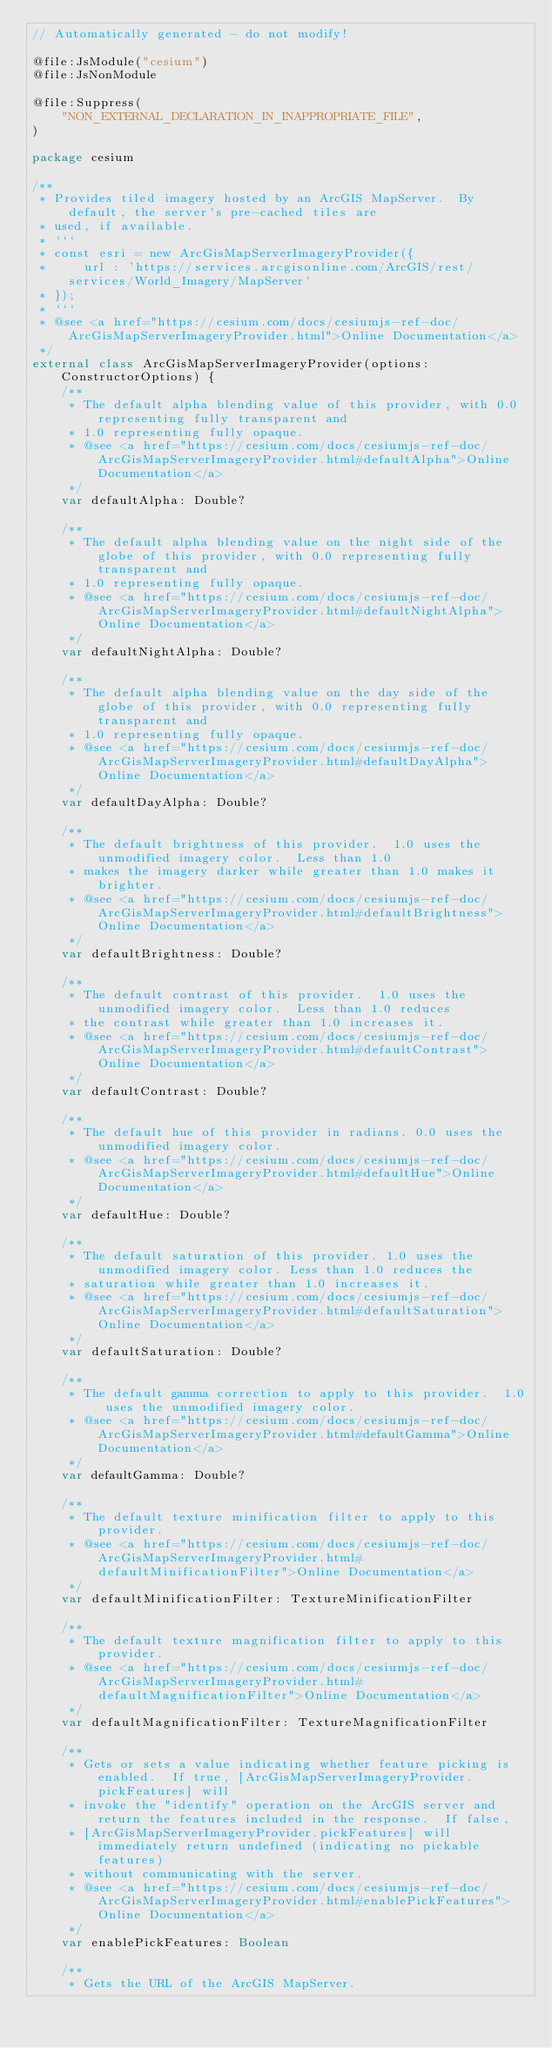<code> <loc_0><loc_0><loc_500><loc_500><_Kotlin_>// Automatically generated - do not modify!

@file:JsModule("cesium")
@file:JsNonModule

@file:Suppress(
    "NON_EXTERNAL_DECLARATION_IN_INAPPROPRIATE_FILE",
)

package cesium

/**
 * Provides tiled imagery hosted by an ArcGIS MapServer.  By default, the server's pre-cached tiles are
 * used, if available.
 * ```
 * const esri = new ArcGisMapServerImageryProvider({
 *     url : 'https://services.arcgisonline.com/ArcGIS/rest/services/World_Imagery/MapServer'
 * });
 * ```
 * @see <a href="https://cesium.com/docs/cesiumjs-ref-doc/ArcGisMapServerImageryProvider.html">Online Documentation</a>
 */
external class ArcGisMapServerImageryProvider(options: ConstructorOptions) {
    /**
     * The default alpha blending value of this provider, with 0.0 representing fully transparent and
     * 1.0 representing fully opaque.
     * @see <a href="https://cesium.com/docs/cesiumjs-ref-doc/ArcGisMapServerImageryProvider.html#defaultAlpha">Online Documentation</a>
     */
    var defaultAlpha: Double?

    /**
     * The default alpha blending value on the night side of the globe of this provider, with 0.0 representing fully transparent and
     * 1.0 representing fully opaque.
     * @see <a href="https://cesium.com/docs/cesiumjs-ref-doc/ArcGisMapServerImageryProvider.html#defaultNightAlpha">Online Documentation</a>
     */
    var defaultNightAlpha: Double?

    /**
     * The default alpha blending value on the day side of the globe of this provider, with 0.0 representing fully transparent and
     * 1.0 representing fully opaque.
     * @see <a href="https://cesium.com/docs/cesiumjs-ref-doc/ArcGisMapServerImageryProvider.html#defaultDayAlpha">Online Documentation</a>
     */
    var defaultDayAlpha: Double?

    /**
     * The default brightness of this provider.  1.0 uses the unmodified imagery color.  Less than 1.0
     * makes the imagery darker while greater than 1.0 makes it brighter.
     * @see <a href="https://cesium.com/docs/cesiumjs-ref-doc/ArcGisMapServerImageryProvider.html#defaultBrightness">Online Documentation</a>
     */
    var defaultBrightness: Double?

    /**
     * The default contrast of this provider.  1.0 uses the unmodified imagery color.  Less than 1.0 reduces
     * the contrast while greater than 1.0 increases it.
     * @see <a href="https://cesium.com/docs/cesiumjs-ref-doc/ArcGisMapServerImageryProvider.html#defaultContrast">Online Documentation</a>
     */
    var defaultContrast: Double?

    /**
     * The default hue of this provider in radians. 0.0 uses the unmodified imagery color.
     * @see <a href="https://cesium.com/docs/cesiumjs-ref-doc/ArcGisMapServerImageryProvider.html#defaultHue">Online Documentation</a>
     */
    var defaultHue: Double?

    /**
     * The default saturation of this provider. 1.0 uses the unmodified imagery color. Less than 1.0 reduces the
     * saturation while greater than 1.0 increases it.
     * @see <a href="https://cesium.com/docs/cesiumjs-ref-doc/ArcGisMapServerImageryProvider.html#defaultSaturation">Online Documentation</a>
     */
    var defaultSaturation: Double?

    /**
     * The default gamma correction to apply to this provider.  1.0 uses the unmodified imagery color.
     * @see <a href="https://cesium.com/docs/cesiumjs-ref-doc/ArcGisMapServerImageryProvider.html#defaultGamma">Online Documentation</a>
     */
    var defaultGamma: Double?

    /**
     * The default texture minification filter to apply to this provider.
     * @see <a href="https://cesium.com/docs/cesiumjs-ref-doc/ArcGisMapServerImageryProvider.html#defaultMinificationFilter">Online Documentation</a>
     */
    var defaultMinificationFilter: TextureMinificationFilter

    /**
     * The default texture magnification filter to apply to this provider.
     * @see <a href="https://cesium.com/docs/cesiumjs-ref-doc/ArcGisMapServerImageryProvider.html#defaultMagnificationFilter">Online Documentation</a>
     */
    var defaultMagnificationFilter: TextureMagnificationFilter

    /**
     * Gets or sets a value indicating whether feature picking is enabled.  If true, [ArcGisMapServerImageryProvider.pickFeatures] will
     * invoke the "identify" operation on the ArcGIS server and return the features included in the response.  If false,
     * [ArcGisMapServerImageryProvider.pickFeatures] will immediately return undefined (indicating no pickable features)
     * without communicating with the server.
     * @see <a href="https://cesium.com/docs/cesiumjs-ref-doc/ArcGisMapServerImageryProvider.html#enablePickFeatures">Online Documentation</a>
     */
    var enablePickFeatures: Boolean

    /**
     * Gets the URL of the ArcGIS MapServer.</code> 